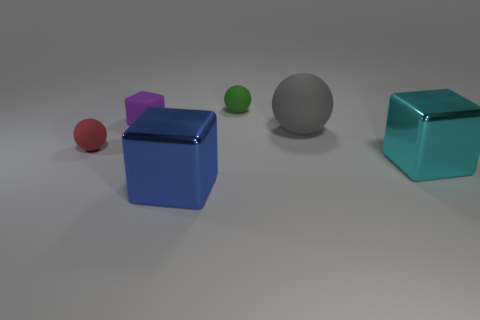Subtract 1 cubes. How many cubes are left? 2 Add 4 large shiny cylinders. How many objects exist? 10 Add 4 small blocks. How many small blocks exist? 5 Subtract 0 green cylinders. How many objects are left? 6 Subtract all small cubes. Subtract all large blue cubes. How many objects are left? 4 Add 2 purple cubes. How many purple cubes are left? 3 